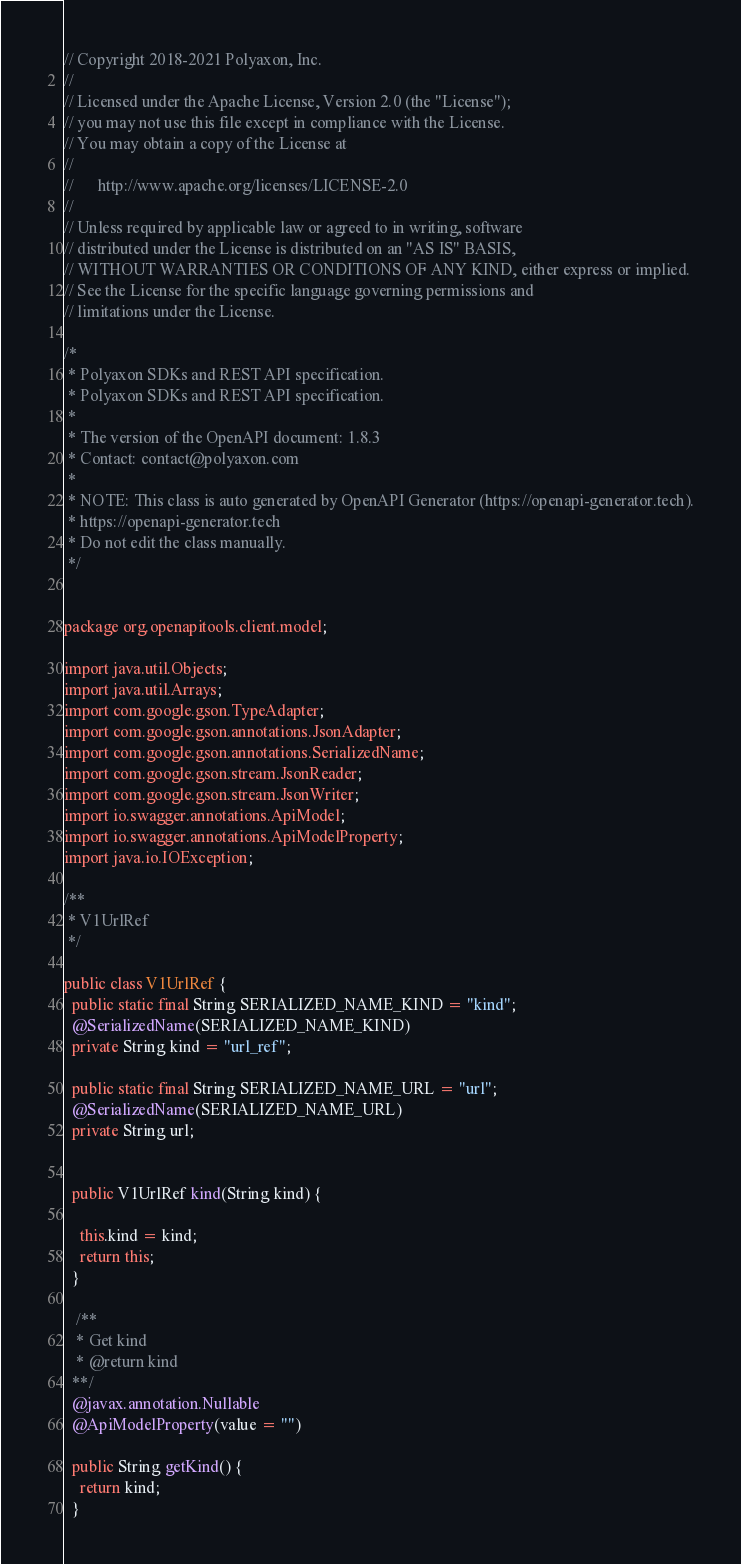<code> <loc_0><loc_0><loc_500><loc_500><_Java_>// Copyright 2018-2021 Polyaxon, Inc.
//
// Licensed under the Apache License, Version 2.0 (the "License");
// you may not use this file except in compliance with the License.
// You may obtain a copy of the License at
//
//      http://www.apache.org/licenses/LICENSE-2.0
//
// Unless required by applicable law or agreed to in writing, software
// distributed under the License is distributed on an "AS IS" BASIS,
// WITHOUT WARRANTIES OR CONDITIONS OF ANY KIND, either express or implied.
// See the License for the specific language governing permissions and
// limitations under the License.

/*
 * Polyaxon SDKs and REST API specification.
 * Polyaxon SDKs and REST API specification.
 *
 * The version of the OpenAPI document: 1.8.3
 * Contact: contact@polyaxon.com
 *
 * NOTE: This class is auto generated by OpenAPI Generator (https://openapi-generator.tech).
 * https://openapi-generator.tech
 * Do not edit the class manually.
 */


package org.openapitools.client.model;

import java.util.Objects;
import java.util.Arrays;
import com.google.gson.TypeAdapter;
import com.google.gson.annotations.JsonAdapter;
import com.google.gson.annotations.SerializedName;
import com.google.gson.stream.JsonReader;
import com.google.gson.stream.JsonWriter;
import io.swagger.annotations.ApiModel;
import io.swagger.annotations.ApiModelProperty;
import java.io.IOException;

/**
 * V1UrlRef
 */

public class V1UrlRef {
  public static final String SERIALIZED_NAME_KIND = "kind";
  @SerializedName(SERIALIZED_NAME_KIND)
  private String kind = "url_ref";

  public static final String SERIALIZED_NAME_URL = "url";
  @SerializedName(SERIALIZED_NAME_URL)
  private String url;


  public V1UrlRef kind(String kind) {
    
    this.kind = kind;
    return this;
  }

   /**
   * Get kind
   * @return kind
  **/
  @javax.annotation.Nullable
  @ApiModelProperty(value = "")

  public String getKind() {
    return kind;
  }

</code> 